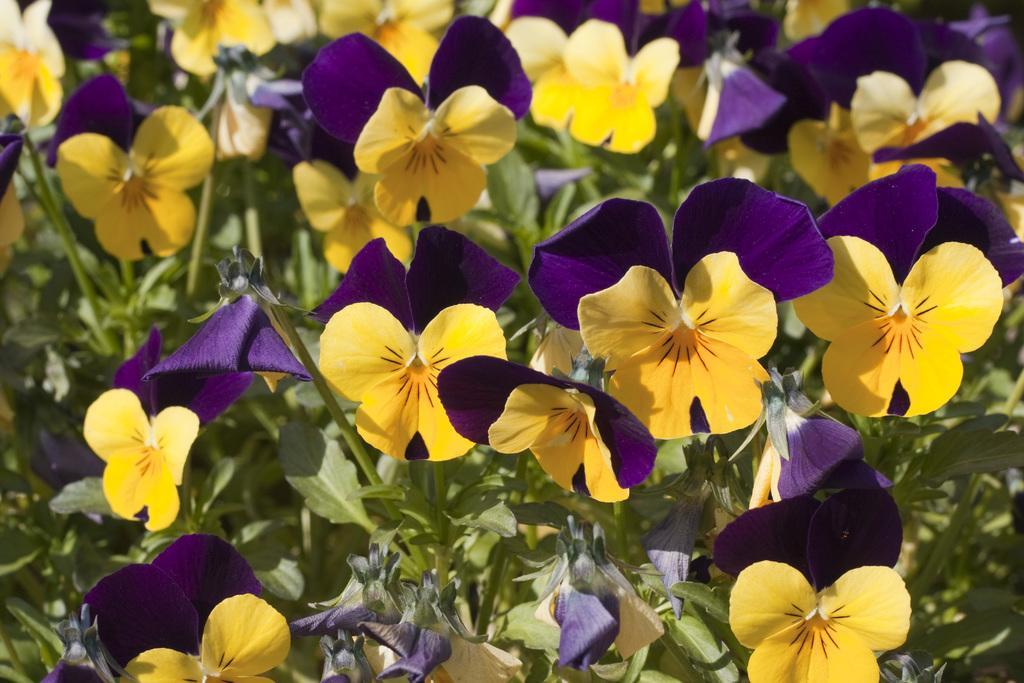Describe this image in one or two sentences. In this picture we can see the plants with the flowers. 